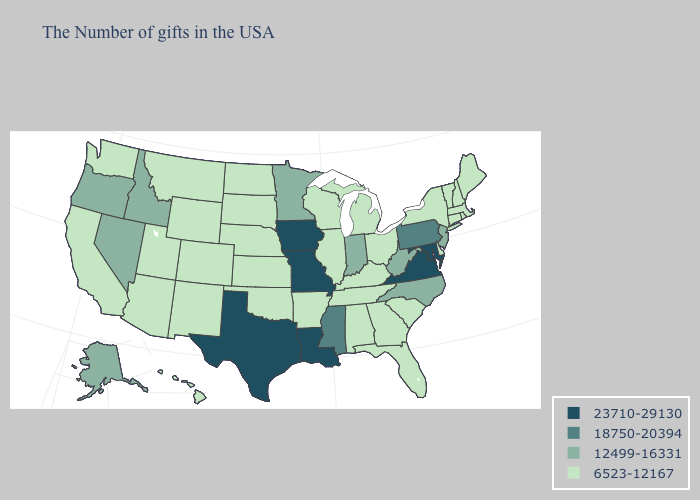Which states have the lowest value in the Northeast?
Give a very brief answer. Maine, Massachusetts, Rhode Island, New Hampshire, Vermont, Connecticut, New York. Name the states that have a value in the range 12499-16331?
Short answer required. New Jersey, North Carolina, West Virginia, Indiana, Minnesota, Idaho, Nevada, Oregon, Alaska. Name the states that have a value in the range 18750-20394?
Write a very short answer. Pennsylvania, Mississippi. Name the states that have a value in the range 6523-12167?
Concise answer only. Maine, Massachusetts, Rhode Island, New Hampshire, Vermont, Connecticut, New York, Delaware, South Carolina, Ohio, Florida, Georgia, Michigan, Kentucky, Alabama, Tennessee, Wisconsin, Illinois, Arkansas, Kansas, Nebraska, Oklahoma, South Dakota, North Dakota, Wyoming, Colorado, New Mexico, Utah, Montana, Arizona, California, Washington, Hawaii. What is the lowest value in the USA?
Keep it brief. 6523-12167. Among the states that border Utah , which have the lowest value?
Give a very brief answer. Wyoming, Colorado, New Mexico, Arizona. Does Rhode Island have the highest value in the Northeast?
Concise answer only. No. Is the legend a continuous bar?
Write a very short answer. No. Among the states that border Nebraska , which have the highest value?
Keep it brief. Missouri, Iowa. Is the legend a continuous bar?
Write a very short answer. No. Among the states that border Ohio , does West Virginia have the lowest value?
Give a very brief answer. No. Among the states that border New Mexico , which have the lowest value?
Short answer required. Oklahoma, Colorado, Utah, Arizona. Which states have the lowest value in the USA?
Short answer required. Maine, Massachusetts, Rhode Island, New Hampshire, Vermont, Connecticut, New York, Delaware, South Carolina, Ohio, Florida, Georgia, Michigan, Kentucky, Alabama, Tennessee, Wisconsin, Illinois, Arkansas, Kansas, Nebraska, Oklahoma, South Dakota, North Dakota, Wyoming, Colorado, New Mexico, Utah, Montana, Arizona, California, Washington, Hawaii. Does the first symbol in the legend represent the smallest category?
Answer briefly. No. Name the states that have a value in the range 12499-16331?
Answer briefly. New Jersey, North Carolina, West Virginia, Indiana, Minnesota, Idaho, Nevada, Oregon, Alaska. 